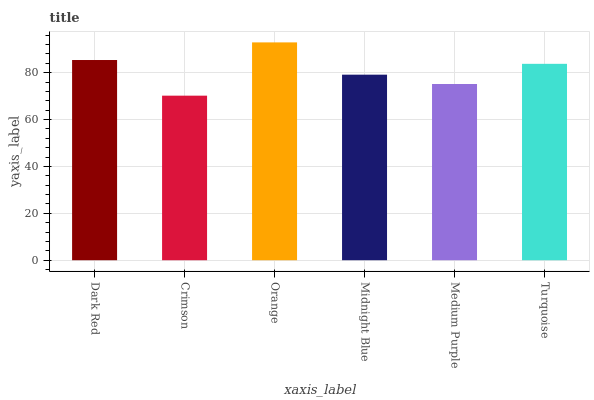Is Orange the minimum?
Answer yes or no. No. Is Crimson the maximum?
Answer yes or no. No. Is Orange greater than Crimson?
Answer yes or no. Yes. Is Crimson less than Orange?
Answer yes or no. Yes. Is Crimson greater than Orange?
Answer yes or no. No. Is Orange less than Crimson?
Answer yes or no. No. Is Turquoise the high median?
Answer yes or no. Yes. Is Midnight Blue the low median?
Answer yes or no. Yes. Is Dark Red the high median?
Answer yes or no. No. Is Turquoise the low median?
Answer yes or no. No. 